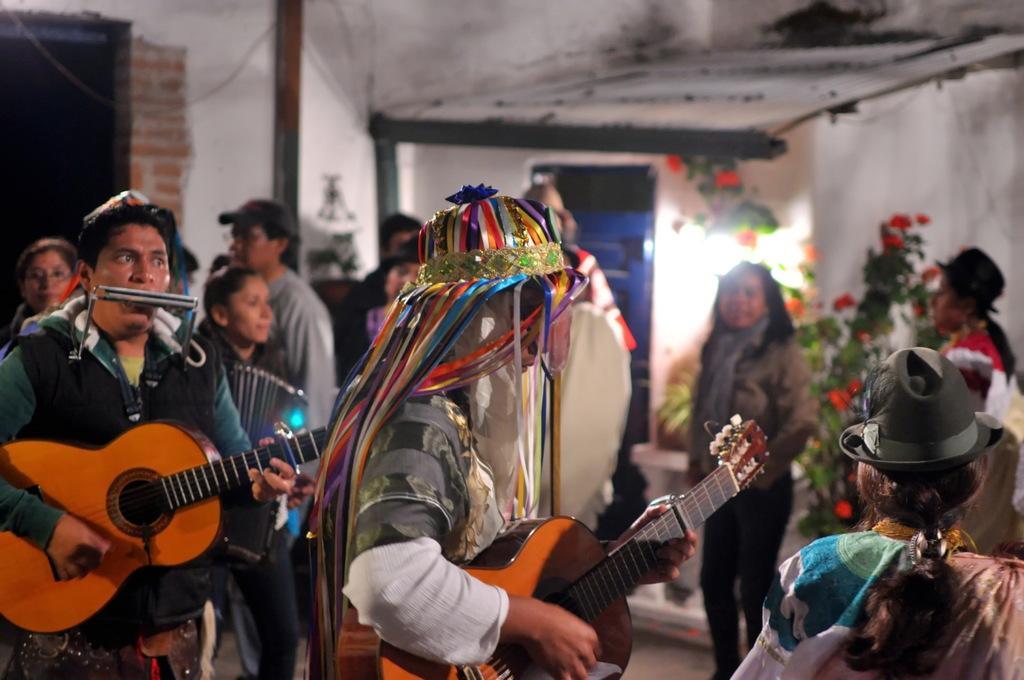Describe this image in one or two sentences. In this picture we can see group of persons playing musical instruments such as guitar, accordion and in the background we can see door, plants, brick wall, pipe here person wore colorful cap. 